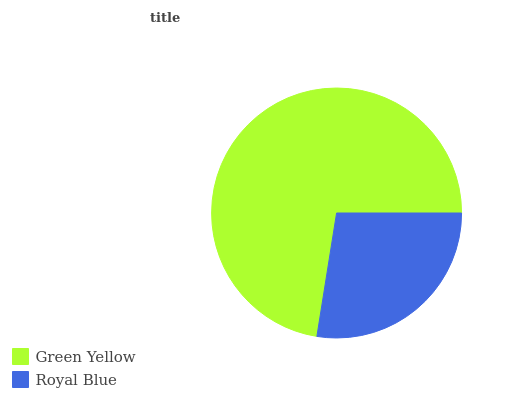Is Royal Blue the minimum?
Answer yes or no. Yes. Is Green Yellow the maximum?
Answer yes or no. Yes. Is Royal Blue the maximum?
Answer yes or no. No. Is Green Yellow greater than Royal Blue?
Answer yes or no. Yes. Is Royal Blue less than Green Yellow?
Answer yes or no. Yes. Is Royal Blue greater than Green Yellow?
Answer yes or no. No. Is Green Yellow less than Royal Blue?
Answer yes or no. No. Is Green Yellow the high median?
Answer yes or no. Yes. Is Royal Blue the low median?
Answer yes or no. Yes. Is Royal Blue the high median?
Answer yes or no. No. Is Green Yellow the low median?
Answer yes or no. No. 